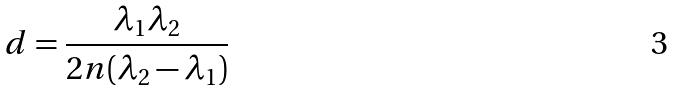Convert formula to latex. <formula><loc_0><loc_0><loc_500><loc_500>d = \frac { \lambda _ { 1 } \lambda _ { 2 } } { 2 n ( \lambda _ { 2 } - \lambda _ { 1 } ) }</formula> 